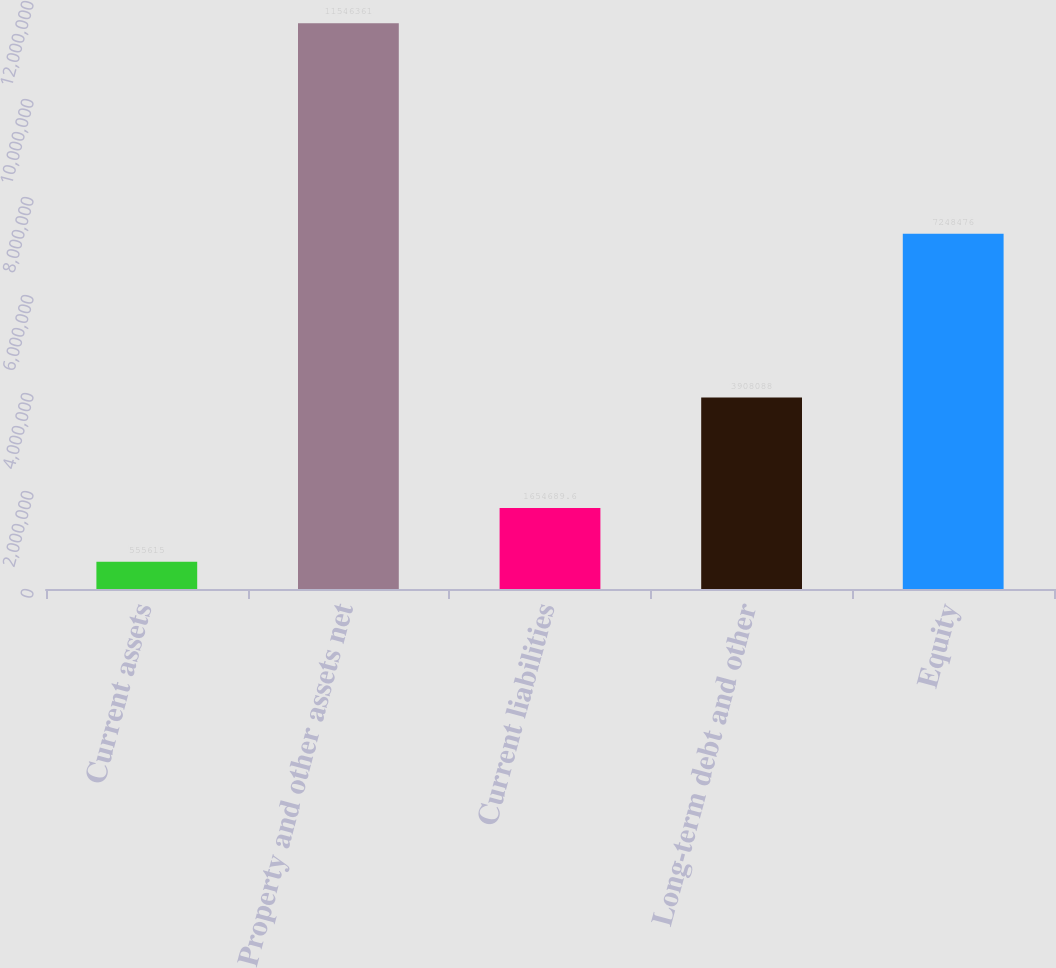<chart> <loc_0><loc_0><loc_500><loc_500><bar_chart><fcel>Current assets<fcel>Property and other assets net<fcel>Current liabilities<fcel>Long-term debt and other<fcel>Equity<nl><fcel>555615<fcel>1.15464e+07<fcel>1.65469e+06<fcel>3.90809e+06<fcel>7.24848e+06<nl></chart> 